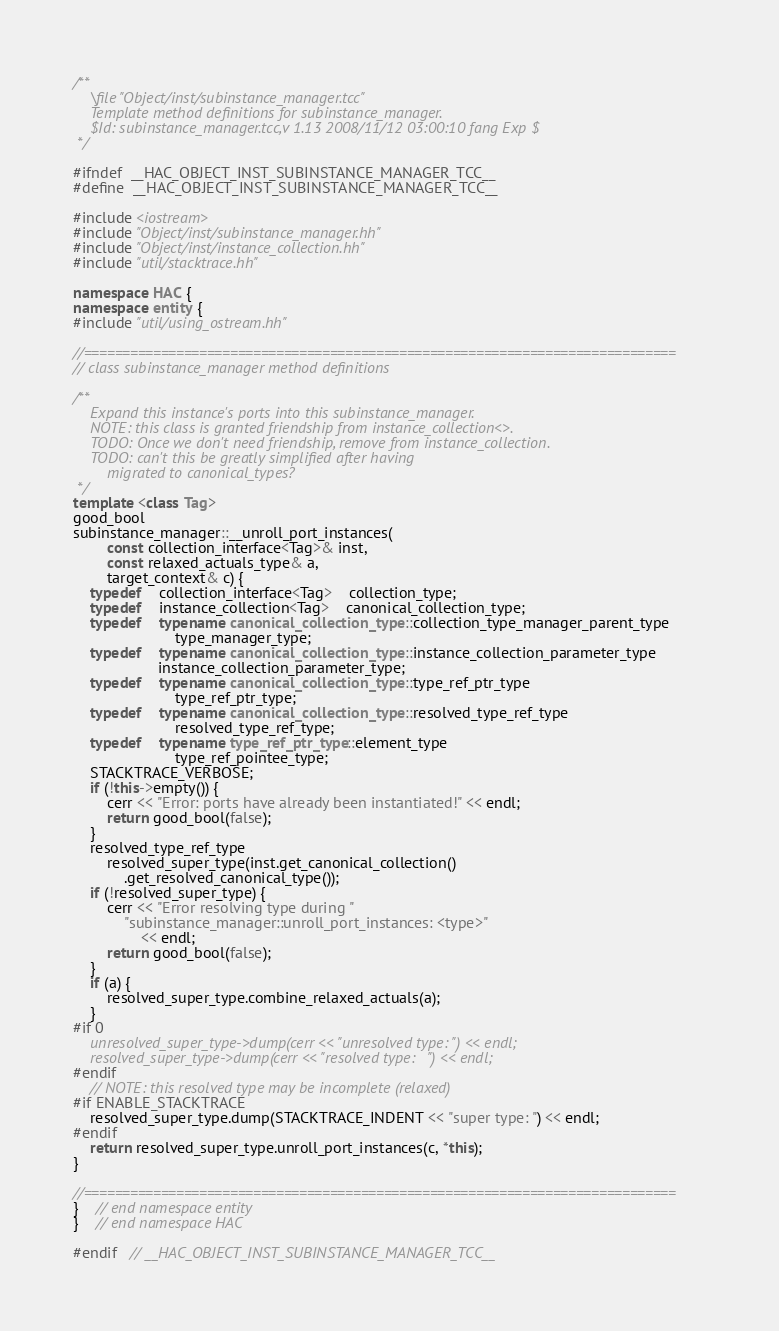<code> <loc_0><loc_0><loc_500><loc_500><_C++_>/**
	\file "Object/inst/subinstance_manager.tcc"
	Template method definitions for subinstance_manager.  
	$Id: subinstance_manager.tcc,v 1.13 2008/11/12 03:00:10 fang Exp $
 */

#ifndef	__HAC_OBJECT_INST_SUBINSTANCE_MANAGER_TCC__
#define	__HAC_OBJECT_INST_SUBINSTANCE_MANAGER_TCC__

#include <iostream>
#include "Object/inst/subinstance_manager.hh"
#include "Object/inst/instance_collection.hh"
#include "util/stacktrace.hh"

namespace HAC {
namespace entity {
#include "util/using_ostream.hh"

//=============================================================================
// class subinstance_manager method definitions

/**
	Expand this instance's ports into this subinstance_manager.  
	NOTE: this class is granted friendship from instance_collection<>.
	TODO: Once we don't need friendship, remove from instance_collection.
	TODO: can't this be greatly simplified after having 
		migrated to canonical_types?
 */
template <class Tag>
good_bool
subinstance_manager::__unroll_port_instances(
		const collection_interface<Tag>& inst, 
		const relaxed_actuals_type& a,
		target_context& c) {
	typedef	collection_interface<Tag>	collection_type;
	typedef	instance_collection<Tag>	canonical_collection_type;
	typedef	typename canonical_collection_type::collection_type_manager_parent_type
						type_manager_type;
	typedef	typename canonical_collection_type::instance_collection_parameter_type
					instance_collection_parameter_type;
	typedef	typename canonical_collection_type::type_ref_ptr_type
						type_ref_ptr_type;
	typedef	typename canonical_collection_type::resolved_type_ref_type
						resolved_type_ref_type;
	typedef	typename type_ref_ptr_type::element_type
						type_ref_pointee_type;
	STACKTRACE_VERBOSE;
	if (!this->empty()) {
		cerr << "Error: ports have already been instantiated!" << endl;
		return good_bool(false);
	}
	resolved_type_ref_type
		resolved_super_type(inst.get_canonical_collection()
			.get_resolved_canonical_type());
	if (!resolved_super_type) {
		cerr << "Error resolving type during "
			"subinstance_manager::unroll_port_instances: <type>"
				<< endl;
		return good_bool(false);
	}
	if (a) {
		resolved_super_type.combine_relaxed_actuals(a);
	}
#if 0
	unresolved_super_type->dump(cerr << "unresolved type: ") << endl;
	resolved_super_type->dump(cerr << "resolved type:   ") << endl;
#endif
	// NOTE: this resolved type may be incomplete (relaxed)
#if ENABLE_STACKTRACE
	resolved_super_type.dump(STACKTRACE_INDENT << "super type: ") << endl;
#endif
	return resolved_super_type.unroll_port_instances(c, *this);
}

//=============================================================================
}	// end namespace entity
}	// end namespace HAC

#endif	// __HAC_OBJECT_INST_SUBINSTANCE_MANAGER_TCC__

</code> 